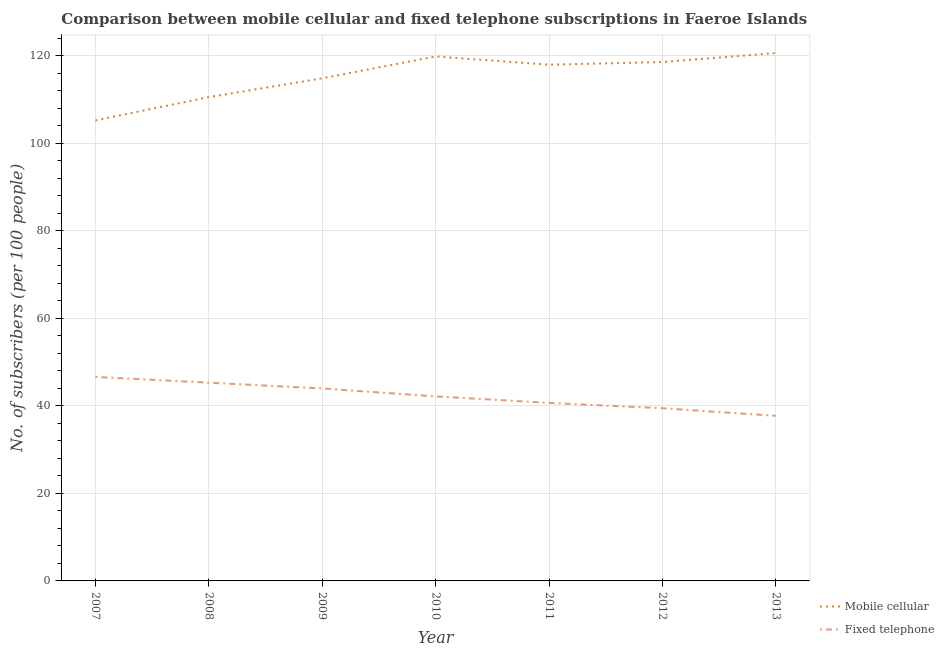How many different coloured lines are there?
Your response must be concise. 2. Is the number of lines equal to the number of legend labels?
Your response must be concise. Yes. What is the number of mobile cellular subscribers in 2007?
Give a very brief answer. 105.28. Across all years, what is the maximum number of mobile cellular subscribers?
Give a very brief answer. 120.68. Across all years, what is the minimum number of fixed telephone subscribers?
Provide a short and direct response. 37.74. What is the total number of fixed telephone subscribers in the graph?
Offer a terse response. 296.05. What is the difference between the number of fixed telephone subscribers in 2010 and that in 2011?
Ensure brevity in your answer.  1.49. What is the difference between the number of mobile cellular subscribers in 2010 and the number of fixed telephone subscribers in 2008?
Make the answer very short. 74.57. What is the average number of mobile cellular subscribers per year?
Your response must be concise. 115.43. In the year 2007, what is the difference between the number of fixed telephone subscribers and number of mobile cellular subscribers?
Make the answer very short. -58.64. In how many years, is the number of mobile cellular subscribers greater than 100?
Provide a short and direct response. 7. What is the ratio of the number of fixed telephone subscribers in 2010 to that in 2013?
Keep it short and to the point. 1.12. Is the difference between the number of fixed telephone subscribers in 2007 and 2008 greater than the difference between the number of mobile cellular subscribers in 2007 and 2008?
Your answer should be compact. Yes. What is the difference between the highest and the second highest number of fixed telephone subscribers?
Offer a terse response. 1.31. What is the difference between the highest and the lowest number of fixed telephone subscribers?
Offer a very short reply. 8.89. Is the sum of the number of fixed telephone subscribers in 2011 and 2013 greater than the maximum number of mobile cellular subscribers across all years?
Ensure brevity in your answer.  No. Is the number of fixed telephone subscribers strictly greater than the number of mobile cellular subscribers over the years?
Offer a terse response. No. How many lines are there?
Keep it short and to the point. 2. How many years are there in the graph?
Your answer should be compact. 7. Are the values on the major ticks of Y-axis written in scientific E-notation?
Provide a succinct answer. No. Does the graph contain any zero values?
Offer a very short reply. No. Does the graph contain grids?
Your answer should be compact. Yes. Where does the legend appear in the graph?
Your response must be concise. Bottom right. How many legend labels are there?
Give a very brief answer. 2. How are the legend labels stacked?
Offer a very short reply. Vertical. What is the title of the graph?
Offer a terse response. Comparison between mobile cellular and fixed telephone subscriptions in Faeroe Islands. Does "Manufacturing industries and construction" appear as one of the legend labels in the graph?
Offer a very short reply. No. What is the label or title of the Y-axis?
Provide a short and direct response. No. of subscribers (per 100 people). What is the No. of subscribers (per 100 people) in Mobile cellular in 2007?
Keep it short and to the point. 105.28. What is the No. of subscribers (per 100 people) of Fixed telephone in 2007?
Make the answer very short. 46.63. What is the No. of subscribers (per 100 people) in Mobile cellular in 2008?
Your answer should be compact. 110.6. What is the No. of subscribers (per 100 people) of Fixed telephone in 2008?
Your answer should be very brief. 45.32. What is the No. of subscribers (per 100 people) in Mobile cellular in 2009?
Make the answer very short. 114.91. What is the No. of subscribers (per 100 people) of Fixed telephone in 2009?
Make the answer very short. 44. What is the No. of subscribers (per 100 people) in Mobile cellular in 2010?
Provide a succinct answer. 119.9. What is the No. of subscribers (per 100 people) in Fixed telephone in 2010?
Provide a succinct answer. 42.19. What is the No. of subscribers (per 100 people) in Mobile cellular in 2011?
Ensure brevity in your answer.  118.01. What is the No. of subscribers (per 100 people) in Fixed telephone in 2011?
Provide a succinct answer. 40.69. What is the No. of subscribers (per 100 people) of Mobile cellular in 2012?
Your answer should be very brief. 118.62. What is the No. of subscribers (per 100 people) of Fixed telephone in 2012?
Provide a succinct answer. 39.48. What is the No. of subscribers (per 100 people) in Mobile cellular in 2013?
Your answer should be very brief. 120.68. What is the No. of subscribers (per 100 people) of Fixed telephone in 2013?
Keep it short and to the point. 37.74. Across all years, what is the maximum No. of subscribers (per 100 people) in Mobile cellular?
Provide a succinct answer. 120.68. Across all years, what is the maximum No. of subscribers (per 100 people) in Fixed telephone?
Provide a short and direct response. 46.63. Across all years, what is the minimum No. of subscribers (per 100 people) of Mobile cellular?
Ensure brevity in your answer.  105.28. Across all years, what is the minimum No. of subscribers (per 100 people) in Fixed telephone?
Your answer should be compact. 37.74. What is the total No. of subscribers (per 100 people) in Mobile cellular in the graph?
Make the answer very short. 807.99. What is the total No. of subscribers (per 100 people) of Fixed telephone in the graph?
Your response must be concise. 296.05. What is the difference between the No. of subscribers (per 100 people) of Mobile cellular in 2007 and that in 2008?
Your response must be concise. -5.33. What is the difference between the No. of subscribers (per 100 people) in Fixed telephone in 2007 and that in 2008?
Your answer should be compact. 1.31. What is the difference between the No. of subscribers (per 100 people) of Mobile cellular in 2007 and that in 2009?
Provide a succinct answer. -9.63. What is the difference between the No. of subscribers (per 100 people) in Fixed telephone in 2007 and that in 2009?
Provide a short and direct response. 2.64. What is the difference between the No. of subscribers (per 100 people) of Mobile cellular in 2007 and that in 2010?
Provide a short and direct response. -14.62. What is the difference between the No. of subscribers (per 100 people) of Fixed telephone in 2007 and that in 2010?
Keep it short and to the point. 4.45. What is the difference between the No. of subscribers (per 100 people) in Mobile cellular in 2007 and that in 2011?
Ensure brevity in your answer.  -12.73. What is the difference between the No. of subscribers (per 100 people) in Fixed telephone in 2007 and that in 2011?
Provide a succinct answer. 5.94. What is the difference between the No. of subscribers (per 100 people) in Mobile cellular in 2007 and that in 2012?
Give a very brief answer. -13.34. What is the difference between the No. of subscribers (per 100 people) in Fixed telephone in 2007 and that in 2012?
Offer a terse response. 7.16. What is the difference between the No. of subscribers (per 100 people) of Mobile cellular in 2007 and that in 2013?
Your answer should be very brief. -15.4. What is the difference between the No. of subscribers (per 100 people) of Fixed telephone in 2007 and that in 2013?
Provide a short and direct response. 8.89. What is the difference between the No. of subscribers (per 100 people) in Mobile cellular in 2008 and that in 2009?
Provide a short and direct response. -4.3. What is the difference between the No. of subscribers (per 100 people) in Fixed telephone in 2008 and that in 2009?
Ensure brevity in your answer.  1.33. What is the difference between the No. of subscribers (per 100 people) of Mobile cellular in 2008 and that in 2010?
Ensure brevity in your answer.  -9.29. What is the difference between the No. of subscribers (per 100 people) of Fixed telephone in 2008 and that in 2010?
Provide a short and direct response. 3.14. What is the difference between the No. of subscribers (per 100 people) in Mobile cellular in 2008 and that in 2011?
Your answer should be very brief. -7.41. What is the difference between the No. of subscribers (per 100 people) in Fixed telephone in 2008 and that in 2011?
Ensure brevity in your answer.  4.63. What is the difference between the No. of subscribers (per 100 people) of Mobile cellular in 2008 and that in 2012?
Provide a short and direct response. -8.01. What is the difference between the No. of subscribers (per 100 people) in Fixed telephone in 2008 and that in 2012?
Give a very brief answer. 5.85. What is the difference between the No. of subscribers (per 100 people) of Mobile cellular in 2008 and that in 2013?
Offer a very short reply. -10.08. What is the difference between the No. of subscribers (per 100 people) in Fixed telephone in 2008 and that in 2013?
Your response must be concise. 7.58. What is the difference between the No. of subscribers (per 100 people) of Mobile cellular in 2009 and that in 2010?
Provide a succinct answer. -4.99. What is the difference between the No. of subscribers (per 100 people) of Fixed telephone in 2009 and that in 2010?
Your response must be concise. 1.81. What is the difference between the No. of subscribers (per 100 people) of Mobile cellular in 2009 and that in 2011?
Provide a short and direct response. -3.1. What is the difference between the No. of subscribers (per 100 people) in Fixed telephone in 2009 and that in 2011?
Offer a terse response. 3.3. What is the difference between the No. of subscribers (per 100 people) in Mobile cellular in 2009 and that in 2012?
Offer a terse response. -3.71. What is the difference between the No. of subscribers (per 100 people) in Fixed telephone in 2009 and that in 2012?
Your response must be concise. 4.52. What is the difference between the No. of subscribers (per 100 people) in Mobile cellular in 2009 and that in 2013?
Make the answer very short. -5.78. What is the difference between the No. of subscribers (per 100 people) of Fixed telephone in 2009 and that in 2013?
Your answer should be compact. 6.25. What is the difference between the No. of subscribers (per 100 people) in Mobile cellular in 2010 and that in 2011?
Offer a very short reply. 1.89. What is the difference between the No. of subscribers (per 100 people) of Fixed telephone in 2010 and that in 2011?
Offer a terse response. 1.49. What is the difference between the No. of subscribers (per 100 people) of Mobile cellular in 2010 and that in 2012?
Offer a very short reply. 1.28. What is the difference between the No. of subscribers (per 100 people) in Fixed telephone in 2010 and that in 2012?
Ensure brevity in your answer.  2.71. What is the difference between the No. of subscribers (per 100 people) in Mobile cellular in 2010 and that in 2013?
Make the answer very short. -0.78. What is the difference between the No. of subscribers (per 100 people) in Fixed telephone in 2010 and that in 2013?
Keep it short and to the point. 4.44. What is the difference between the No. of subscribers (per 100 people) in Mobile cellular in 2011 and that in 2012?
Give a very brief answer. -0.61. What is the difference between the No. of subscribers (per 100 people) in Fixed telephone in 2011 and that in 2012?
Your response must be concise. 1.21. What is the difference between the No. of subscribers (per 100 people) in Mobile cellular in 2011 and that in 2013?
Ensure brevity in your answer.  -2.67. What is the difference between the No. of subscribers (per 100 people) in Fixed telephone in 2011 and that in 2013?
Your response must be concise. 2.95. What is the difference between the No. of subscribers (per 100 people) in Mobile cellular in 2012 and that in 2013?
Your response must be concise. -2.07. What is the difference between the No. of subscribers (per 100 people) in Fixed telephone in 2012 and that in 2013?
Give a very brief answer. 1.73. What is the difference between the No. of subscribers (per 100 people) in Mobile cellular in 2007 and the No. of subscribers (per 100 people) in Fixed telephone in 2008?
Make the answer very short. 59.95. What is the difference between the No. of subscribers (per 100 people) of Mobile cellular in 2007 and the No. of subscribers (per 100 people) of Fixed telephone in 2009?
Keep it short and to the point. 61.28. What is the difference between the No. of subscribers (per 100 people) in Mobile cellular in 2007 and the No. of subscribers (per 100 people) in Fixed telephone in 2010?
Keep it short and to the point. 63.09. What is the difference between the No. of subscribers (per 100 people) of Mobile cellular in 2007 and the No. of subscribers (per 100 people) of Fixed telephone in 2011?
Keep it short and to the point. 64.59. What is the difference between the No. of subscribers (per 100 people) in Mobile cellular in 2007 and the No. of subscribers (per 100 people) in Fixed telephone in 2012?
Provide a succinct answer. 65.8. What is the difference between the No. of subscribers (per 100 people) of Mobile cellular in 2007 and the No. of subscribers (per 100 people) of Fixed telephone in 2013?
Your answer should be compact. 67.53. What is the difference between the No. of subscribers (per 100 people) in Mobile cellular in 2008 and the No. of subscribers (per 100 people) in Fixed telephone in 2009?
Keep it short and to the point. 66.61. What is the difference between the No. of subscribers (per 100 people) in Mobile cellular in 2008 and the No. of subscribers (per 100 people) in Fixed telephone in 2010?
Keep it short and to the point. 68.42. What is the difference between the No. of subscribers (per 100 people) of Mobile cellular in 2008 and the No. of subscribers (per 100 people) of Fixed telephone in 2011?
Provide a short and direct response. 69.91. What is the difference between the No. of subscribers (per 100 people) of Mobile cellular in 2008 and the No. of subscribers (per 100 people) of Fixed telephone in 2012?
Make the answer very short. 71.13. What is the difference between the No. of subscribers (per 100 people) of Mobile cellular in 2008 and the No. of subscribers (per 100 people) of Fixed telephone in 2013?
Offer a very short reply. 72.86. What is the difference between the No. of subscribers (per 100 people) in Mobile cellular in 2009 and the No. of subscribers (per 100 people) in Fixed telephone in 2010?
Offer a terse response. 72.72. What is the difference between the No. of subscribers (per 100 people) in Mobile cellular in 2009 and the No. of subscribers (per 100 people) in Fixed telephone in 2011?
Make the answer very short. 74.21. What is the difference between the No. of subscribers (per 100 people) in Mobile cellular in 2009 and the No. of subscribers (per 100 people) in Fixed telephone in 2012?
Provide a succinct answer. 75.43. What is the difference between the No. of subscribers (per 100 people) in Mobile cellular in 2009 and the No. of subscribers (per 100 people) in Fixed telephone in 2013?
Make the answer very short. 77.16. What is the difference between the No. of subscribers (per 100 people) in Mobile cellular in 2010 and the No. of subscribers (per 100 people) in Fixed telephone in 2011?
Offer a very short reply. 79.21. What is the difference between the No. of subscribers (per 100 people) of Mobile cellular in 2010 and the No. of subscribers (per 100 people) of Fixed telephone in 2012?
Make the answer very short. 80.42. What is the difference between the No. of subscribers (per 100 people) of Mobile cellular in 2010 and the No. of subscribers (per 100 people) of Fixed telephone in 2013?
Ensure brevity in your answer.  82.15. What is the difference between the No. of subscribers (per 100 people) of Mobile cellular in 2011 and the No. of subscribers (per 100 people) of Fixed telephone in 2012?
Ensure brevity in your answer.  78.53. What is the difference between the No. of subscribers (per 100 people) of Mobile cellular in 2011 and the No. of subscribers (per 100 people) of Fixed telephone in 2013?
Make the answer very short. 80.27. What is the difference between the No. of subscribers (per 100 people) in Mobile cellular in 2012 and the No. of subscribers (per 100 people) in Fixed telephone in 2013?
Ensure brevity in your answer.  80.87. What is the average No. of subscribers (per 100 people) of Mobile cellular per year?
Your answer should be very brief. 115.43. What is the average No. of subscribers (per 100 people) in Fixed telephone per year?
Provide a succinct answer. 42.29. In the year 2007, what is the difference between the No. of subscribers (per 100 people) in Mobile cellular and No. of subscribers (per 100 people) in Fixed telephone?
Provide a short and direct response. 58.64. In the year 2008, what is the difference between the No. of subscribers (per 100 people) of Mobile cellular and No. of subscribers (per 100 people) of Fixed telephone?
Your answer should be compact. 65.28. In the year 2009, what is the difference between the No. of subscribers (per 100 people) of Mobile cellular and No. of subscribers (per 100 people) of Fixed telephone?
Your answer should be compact. 70.91. In the year 2010, what is the difference between the No. of subscribers (per 100 people) in Mobile cellular and No. of subscribers (per 100 people) in Fixed telephone?
Keep it short and to the point. 77.71. In the year 2011, what is the difference between the No. of subscribers (per 100 people) in Mobile cellular and No. of subscribers (per 100 people) in Fixed telephone?
Offer a terse response. 77.32. In the year 2012, what is the difference between the No. of subscribers (per 100 people) in Mobile cellular and No. of subscribers (per 100 people) in Fixed telephone?
Provide a short and direct response. 79.14. In the year 2013, what is the difference between the No. of subscribers (per 100 people) in Mobile cellular and No. of subscribers (per 100 people) in Fixed telephone?
Provide a short and direct response. 82.94. What is the ratio of the No. of subscribers (per 100 people) in Mobile cellular in 2007 to that in 2008?
Offer a very short reply. 0.95. What is the ratio of the No. of subscribers (per 100 people) of Fixed telephone in 2007 to that in 2008?
Your answer should be compact. 1.03. What is the ratio of the No. of subscribers (per 100 people) in Mobile cellular in 2007 to that in 2009?
Your answer should be compact. 0.92. What is the ratio of the No. of subscribers (per 100 people) in Fixed telephone in 2007 to that in 2009?
Your answer should be very brief. 1.06. What is the ratio of the No. of subscribers (per 100 people) in Mobile cellular in 2007 to that in 2010?
Your answer should be compact. 0.88. What is the ratio of the No. of subscribers (per 100 people) in Fixed telephone in 2007 to that in 2010?
Your answer should be compact. 1.11. What is the ratio of the No. of subscribers (per 100 people) of Mobile cellular in 2007 to that in 2011?
Provide a short and direct response. 0.89. What is the ratio of the No. of subscribers (per 100 people) of Fixed telephone in 2007 to that in 2011?
Provide a succinct answer. 1.15. What is the ratio of the No. of subscribers (per 100 people) in Mobile cellular in 2007 to that in 2012?
Offer a very short reply. 0.89. What is the ratio of the No. of subscribers (per 100 people) in Fixed telephone in 2007 to that in 2012?
Offer a very short reply. 1.18. What is the ratio of the No. of subscribers (per 100 people) of Mobile cellular in 2007 to that in 2013?
Provide a short and direct response. 0.87. What is the ratio of the No. of subscribers (per 100 people) in Fixed telephone in 2007 to that in 2013?
Your response must be concise. 1.24. What is the ratio of the No. of subscribers (per 100 people) of Mobile cellular in 2008 to that in 2009?
Provide a short and direct response. 0.96. What is the ratio of the No. of subscribers (per 100 people) of Fixed telephone in 2008 to that in 2009?
Provide a succinct answer. 1.03. What is the ratio of the No. of subscribers (per 100 people) in Mobile cellular in 2008 to that in 2010?
Offer a very short reply. 0.92. What is the ratio of the No. of subscribers (per 100 people) of Fixed telephone in 2008 to that in 2010?
Your answer should be very brief. 1.07. What is the ratio of the No. of subscribers (per 100 people) in Mobile cellular in 2008 to that in 2011?
Make the answer very short. 0.94. What is the ratio of the No. of subscribers (per 100 people) in Fixed telephone in 2008 to that in 2011?
Keep it short and to the point. 1.11. What is the ratio of the No. of subscribers (per 100 people) in Mobile cellular in 2008 to that in 2012?
Ensure brevity in your answer.  0.93. What is the ratio of the No. of subscribers (per 100 people) in Fixed telephone in 2008 to that in 2012?
Give a very brief answer. 1.15. What is the ratio of the No. of subscribers (per 100 people) of Mobile cellular in 2008 to that in 2013?
Give a very brief answer. 0.92. What is the ratio of the No. of subscribers (per 100 people) of Fixed telephone in 2008 to that in 2013?
Offer a terse response. 1.2. What is the ratio of the No. of subscribers (per 100 people) in Mobile cellular in 2009 to that in 2010?
Your answer should be very brief. 0.96. What is the ratio of the No. of subscribers (per 100 people) in Fixed telephone in 2009 to that in 2010?
Make the answer very short. 1.04. What is the ratio of the No. of subscribers (per 100 people) in Mobile cellular in 2009 to that in 2011?
Provide a succinct answer. 0.97. What is the ratio of the No. of subscribers (per 100 people) in Fixed telephone in 2009 to that in 2011?
Offer a very short reply. 1.08. What is the ratio of the No. of subscribers (per 100 people) of Mobile cellular in 2009 to that in 2012?
Provide a succinct answer. 0.97. What is the ratio of the No. of subscribers (per 100 people) of Fixed telephone in 2009 to that in 2012?
Ensure brevity in your answer.  1.11. What is the ratio of the No. of subscribers (per 100 people) of Mobile cellular in 2009 to that in 2013?
Provide a short and direct response. 0.95. What is the ratio of the No. of subscribers (per 100 people) in Fixed telephone in 2009 to that in 2013?
Your answer should be compact. 1.17. What is the ratio of the No. of subscribers (per 100 people) in Mobile cellular in 2010 to that in 2011?
Keep it short and to the point. 1.02. What is the ratio of the No. of subscribers (per 100 people) of Fixed telephone in 2010 to that in 2011?
Your answer should be very brief. 1.04. What is the ratio of the No. of subscribers (per 100 people) in Mobile cellular in 2010 to that in 2012?
Offer a terse response. 1.01. What is the ratio of the No. of subscribers (per 100 people) in Fixed telephone in 2010 to that in 2012?
Provide a succinct answer. 1.07. What is the ratio of the No. of subscribers (per 100 people) of Mobile cellular in 2010 to that in 2013?
Make the answer very short. 0.99. What is the ratio of the No. of subscribers (per 100 people) of Fixed telephone in 2010 to that in 2013?
Your answer should be compact. 1.12. What is the ratio of the No. of subscribers (per 100 people) in Fixed telephone in 2011 to that in 2012?
Ensure brevity in your answer.  1.03. What is the ratio of the No. of subscribers (per 100 people) of Mobile cellular in 2011 to that in 2013?
Keep it short and to the point. 0.98. What is the ratio of the No. of subscribers (per 100 people) in Fixed telephone in 2011 to that in 2013?
Your response must be concise. 1.08. What is the ratio of the No. of subscribers (per 100 people) of Mobile cellular in 2012 to that in 2013?
Offer a very short reply. 0.98. What is the ratio of the No. of subscribers (per 100 people) in Fixed telephone in 2012 to that in 2013?
Provide a short and direct response. 1.05. What is the difference between the highest and the second highest No. of subscribers (per 100 people) of Mobile cellular?
Your response must be concise. 0.78. What is the difference between the highest and the second highest No. of subscribers (per 100 people) of Fixed telephone?
Offer a very short reply. 1.31. What is the difference between the highest and the lowest No. of subscribers (per 100 people) of Mobile cellular?
Give a very brief answer. 15.4. What is the difference between the highest and the lowest No. of subscribers (per 100 people) in Fixed telephone?
Offer a terse response. 8.89. 